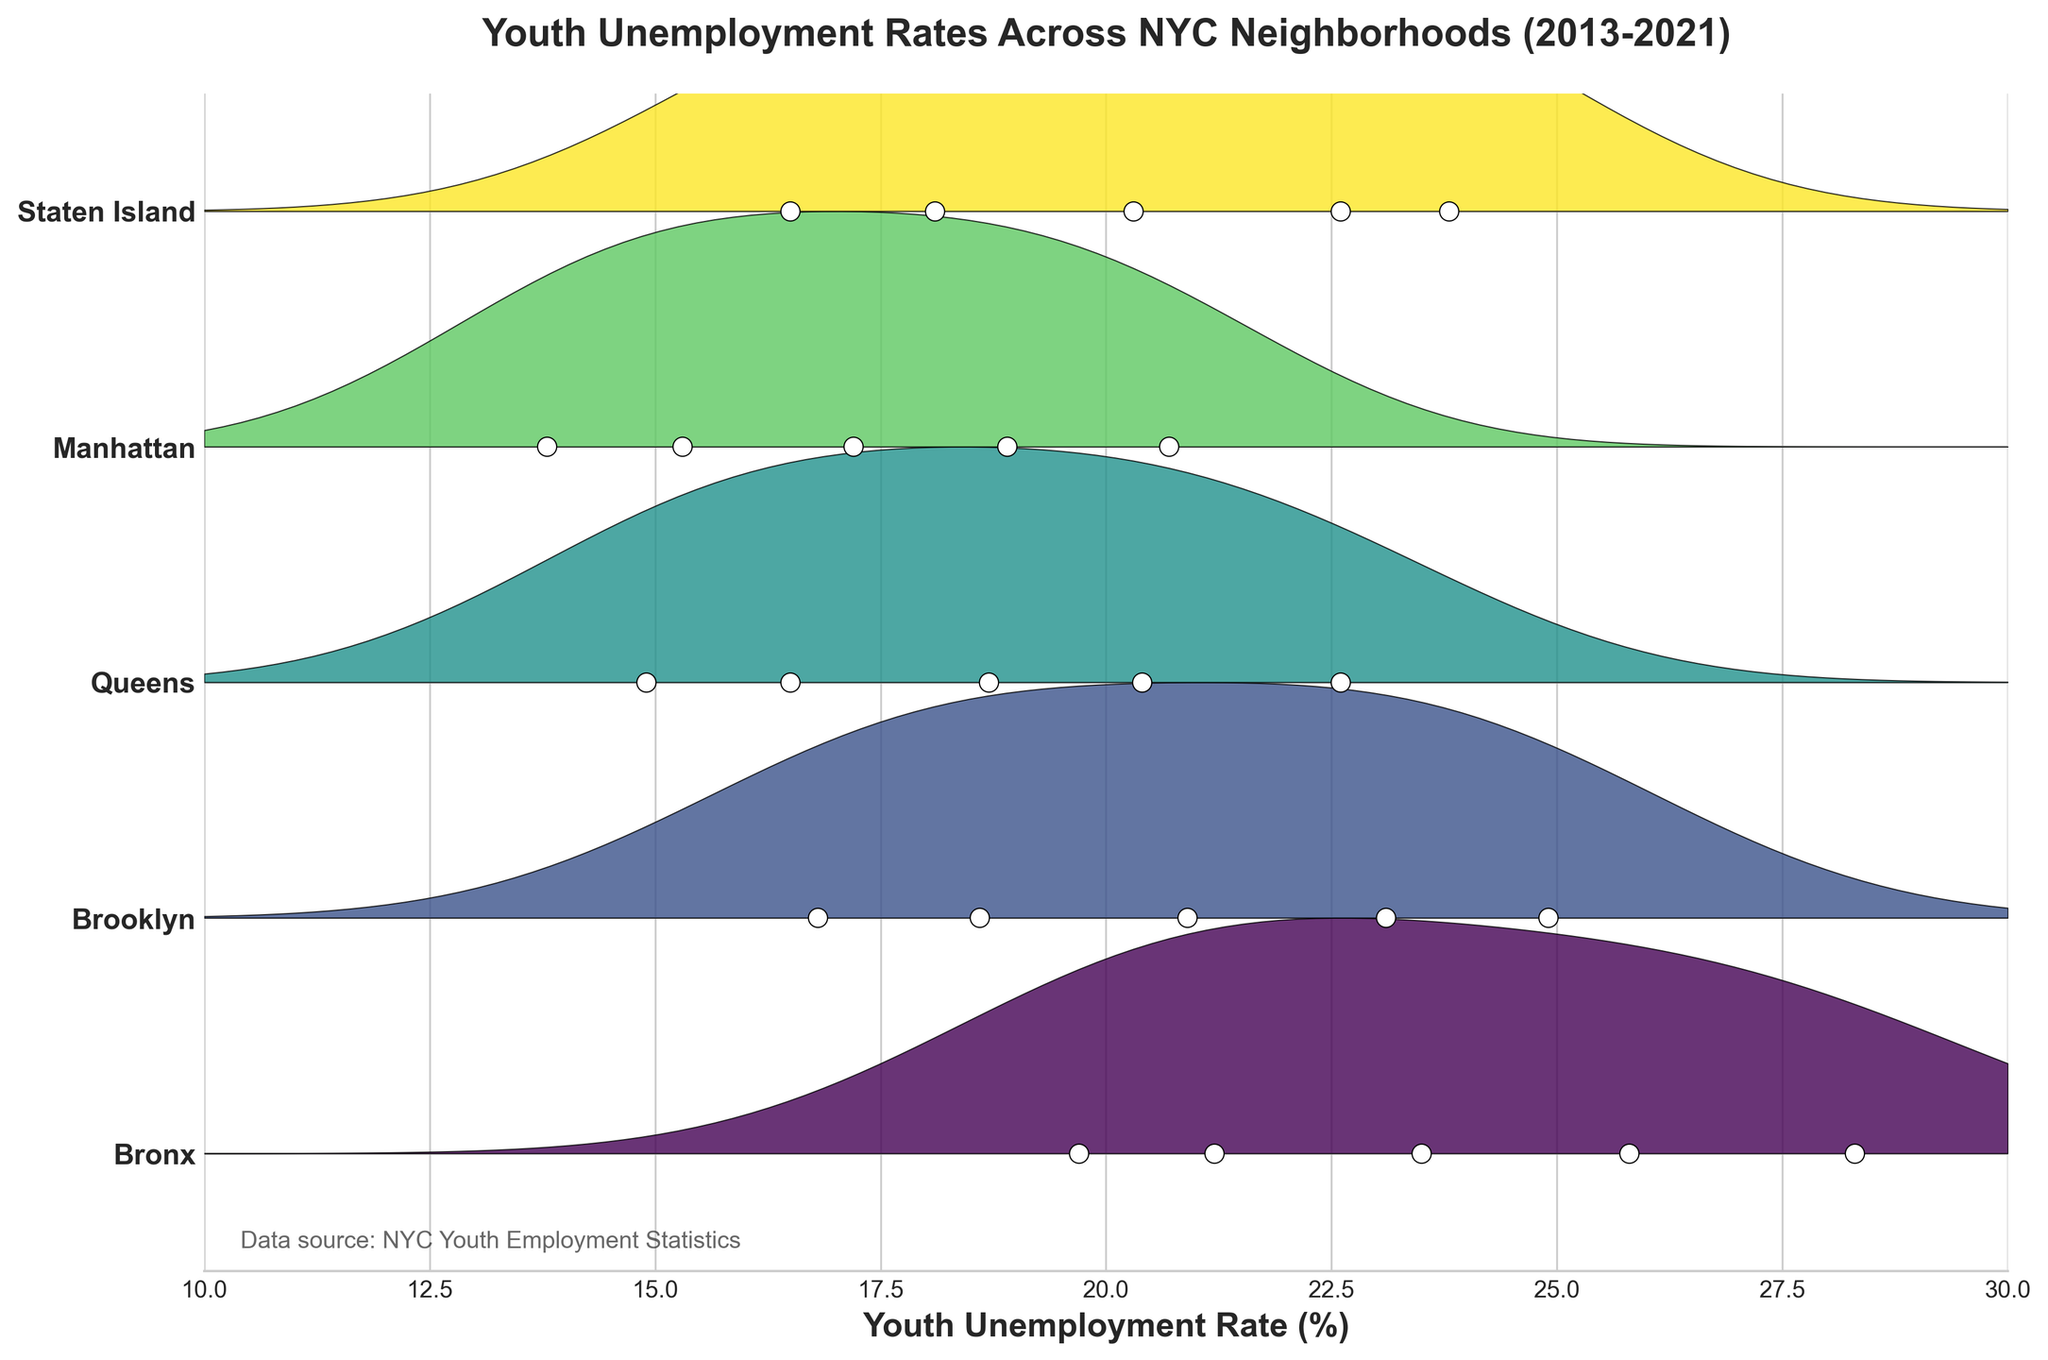Which neighborhood has the title shown in the figure? The title "Youth Unemployment Rates Across NYC Neighborhoods (2013-2021)" indicates that the figure includes data from all neighborhoods mentioned in the dataset (Bronx, Brooklyn, Queens, Manhattan, Staten Island).
Answer: All neighborhoods What is the title of the figure? The title is shown at the top of the figure, providing an overview of the data represented.
Answer: Youth Unemployment Rates Across NYC Neighborhoods (2013-2021) How does the youth unemployment rate trend for the Bronx change between 2013 and 2021? By looking at the filled areas for the Bronx, we notice the values start at around 25.8% in 2013, decrease over the years until 2019, and then spike up to 28.3% in 2021.
Answer: Decreases then rises Which neighborhood had the highest youth unemployment rate in 2021? By observing the highest points of the filled areas for each neighborhood in 2021, the Bronx reaches the highest unemployment rate of 28.3%.
Answer: Bronx How do the unemployment rates for Brooklyn and Queens compare in 2017? For 2017, Brooklyn has a lower unemployment rate of 18.6%, whereas Queens is slightly lower at 16.5%. This can be observed from the dots and the filled areas for these two neighborhoods.
Answer: Brooklyn is higher Which neighborhood shows the most significant increase in youth unemployment rate from 2019 to 2021? By comparing the differences between 2019 and 2021, the Bronx's unemployment rate increases from 19.7% to 28.3%, making it the most significant increase among the neighborhoods.
Answer: Bronx What general trend in youth unemployment can be observed across the neighborhoods from 2013 to 2019? The general trend across all neighborhoods from 2013 to 2019 is a decline in youth unemployment rates. This can be identified by the downward slopes of the filled areas across all neighborhoods.
Answer: Decline Which neighborhood shows the least variation in youth unemployment rates across the years? By observing the width and variability of the filled areas, Manhattan shows the least variation in unemployment rates over the years.
Answer: Manhattan What is the average youth unemployment rate for Queens from 2013 to 2021? Adding the unemployment rates for Queens (20.4, 18.7, 16.5, 14.9, 22.6), then dividing by 5 gives the average rate. (20.4 + 18.7 + 16.5 + 14.9 + 22.6) / 5 = 18.62%
Answer: 18.62% Which neighborhoods have a youth unemployment rate lower than 15% at any point? By observing the filled areas and dots, Manhattan and Queens have unemployment rates lower than 15% in 2019 (13.8% and 14.9%, respectively).
Answer: Manhattan and Queens 